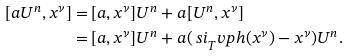Convert formula to latex. <formula><loc_0><loc_0><loc_500><loc_500>[ a U ^ { n } , x ^ { \nu } ] = & \, [ a , x ^ { \nu } ] U ^ { n } + a [ U ^ { n } , x ^ { \nu } ] \\ = & \, [ a , x ^ { \nu } ] U ^ { n } + a ( \ s i _ { T } ^ { \ } v p h ( x ^ { \nu } ) - x ^ { \nu } ) U ^ { n } .</formula> 